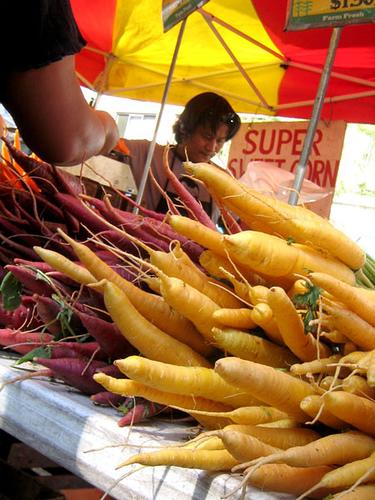What is covering the man?
Short answer required. Umbrella. Is it a sunny day?
Keep it brief. Yes. What color is the tent?
Quick response, please. Red and yellow. Is this a vegetable market?
Write a very short answer. Yes. What color are the vegetables?
Give a very brief answer. Orange and red. 